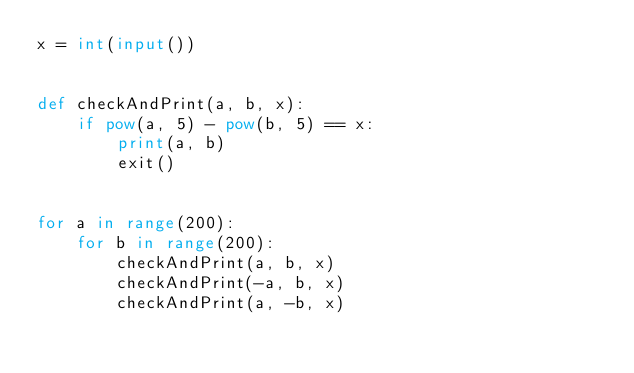<code> <loc_0><loc_0><loc_500><loc_500><_Python_>x = int(input())


def checkAndPrint(a, b, x):
    if pow(a, 5) - pow(b, 5) == x:
        print(a, b)
        exit()


for a in range(200):
    for b in range(200):
        checkAndPrint(a, b, x)
        checkAndPrint(-a, b, x)
        checkAndPrint(a, -b, x)</code> 